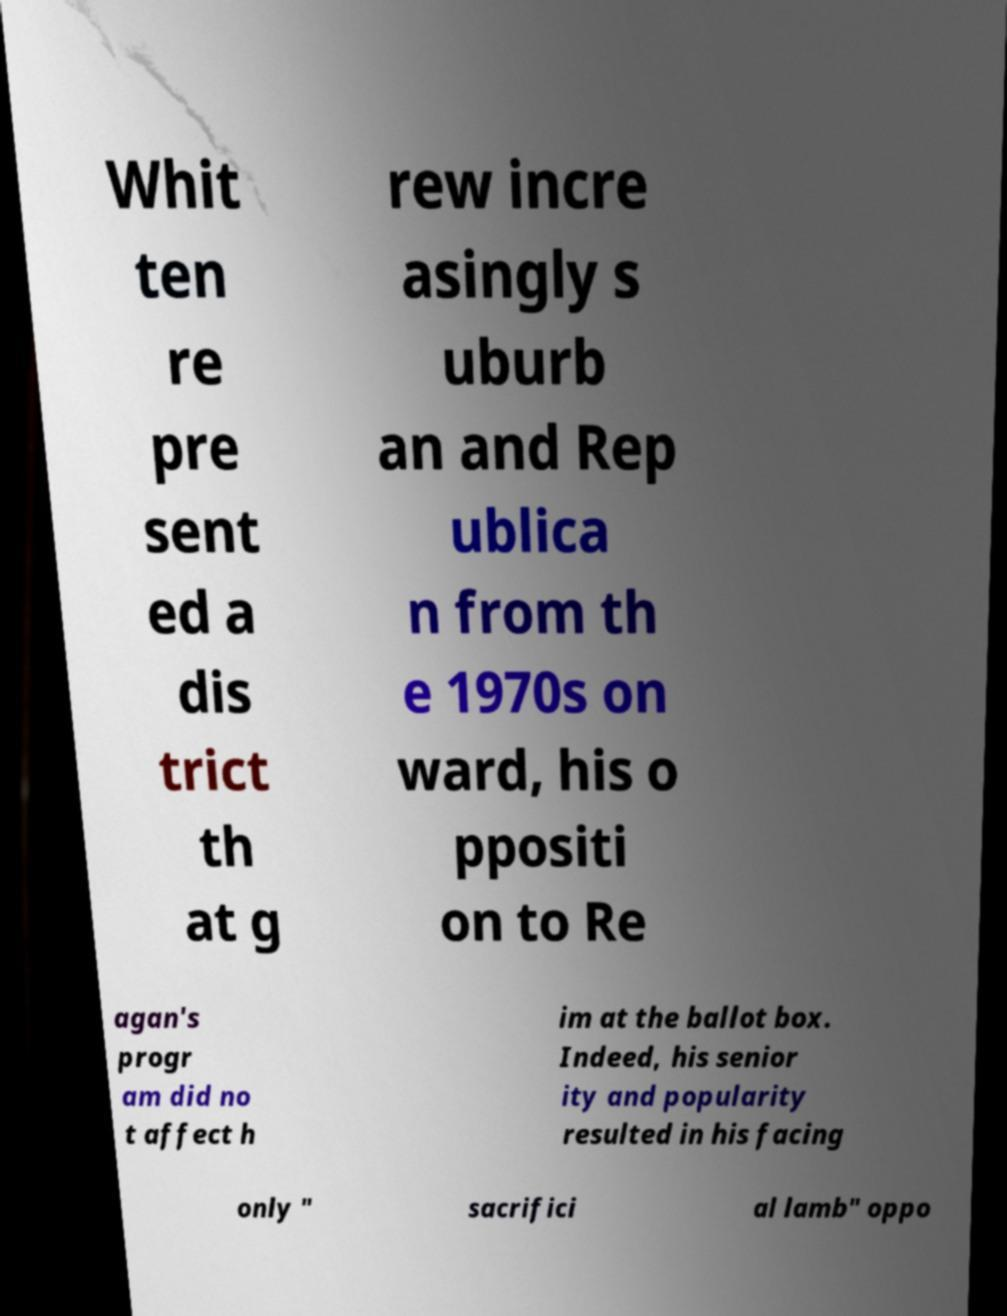Please read and relay the text visible in this image. What does it say? Whit ten re pre sent ed a dis trict th at g rew incre asingly s uburb an and Rep ublica n from th e 1970s on ward, his o ppositi on to Re agan's progr am did no t affect h im at the ballot box. Indeed, his senior ity and popularity resulted in his facing only " sacrifici al lamb" oppo 